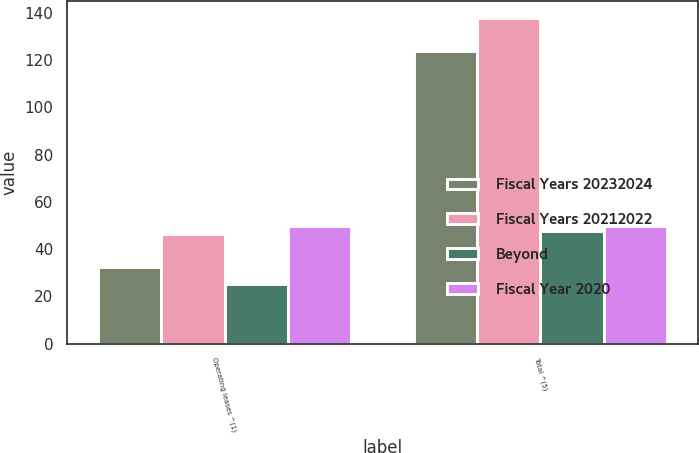Convert chart. <chart><loc_0><loc_0><loc_500><loc_500><stacked_bar_chart><ecel><fcel>Operating leases ^(1)<fcel>Total ^(5)<nl><fcel>Fiscal Years 20232024<fcel>32.5<fcel>123.8<nl><fcel>Fiscal Years 20212022<fcel>46.5<fcel>138<nl><fcel>Beyond<fcel>25.4<fcel>47.5<nl><fcel>Fiscal Year 2020<fcel>49.9<fcel>49.9<nl></chart> 